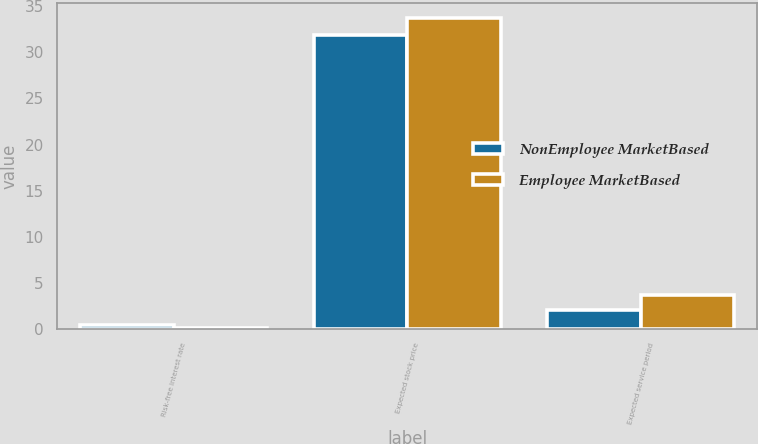<chart> <loc_0><loc_0><loc_500><loc_500><stacked_bar_chart><ecel><fcel>Risk-free interest rate<fcel>Expected stock price<fcel>Expected service period<nl><fcel>NonEmployee MarketBased<fcel>0.4<fcel>31.9<fcel>2<nl><fcel>Employee MarketBased<fcel>0.1<fcel>33.7<fcel>3.7<nl></chart> 